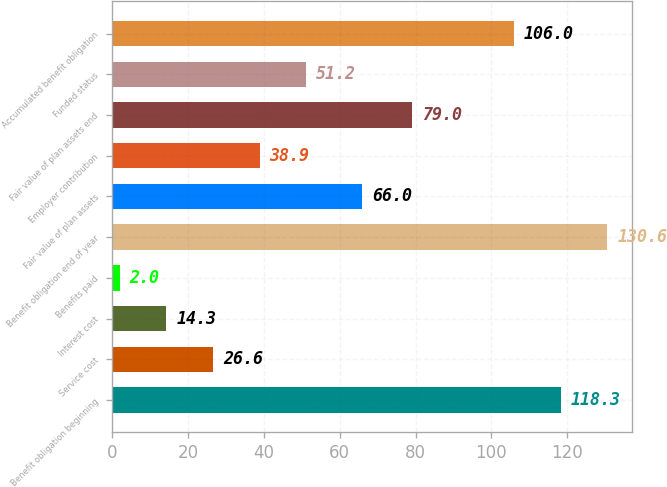<chart> <loc_0><loc_0><loc_500><loc_500><bar_chart><fcel>Benefit obligation beginning<fcel>Service cost<fcel>Interest cost<fcel>Benefits paid<fcel>Benefit obligation end of year<fcel>Fair value of plan assets<fcel>Employer contribution<fcel>Fair value of plan assets end<fcel>Funded status<fcel>Accumulated benefit obligation<nl><fcel>118.3<fcel>26.6<fcel>14.3<fcel>2<fcel>130.6<fcel>66<fcel>38.9<fcel>79<fcel>51.2<fcel>106<nl></chart> 